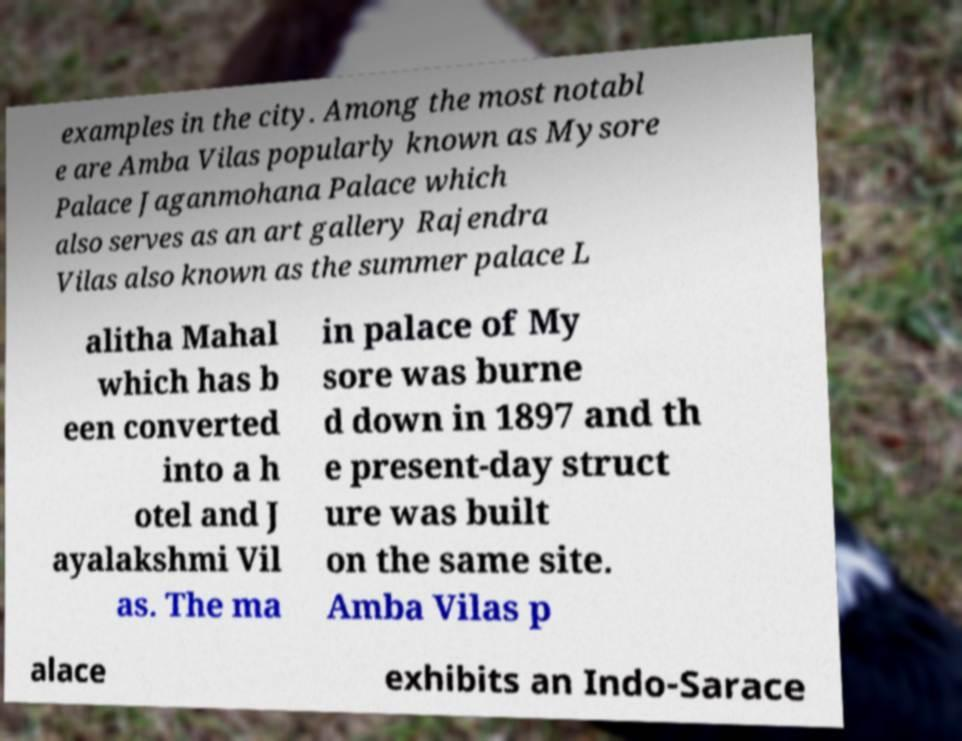There's text embedded in this image that I need extracted. Can you transcribe it verbatim? examples in the city. Among the most notabl e are Amba Vilas popularly known as Mysore Palace Jaganmohana Palace which also serves as an art gallery Rajendra Vilas also known as the summer palace L alitha Mahal which has b een converted into a h otel and J ayalakshmi Vil as. The ma in palace of My sore was burne d down in 1897 and th e present-day struct ure was built on the same site. Amba Vilas p alace exhibits an Indo-Sarace 